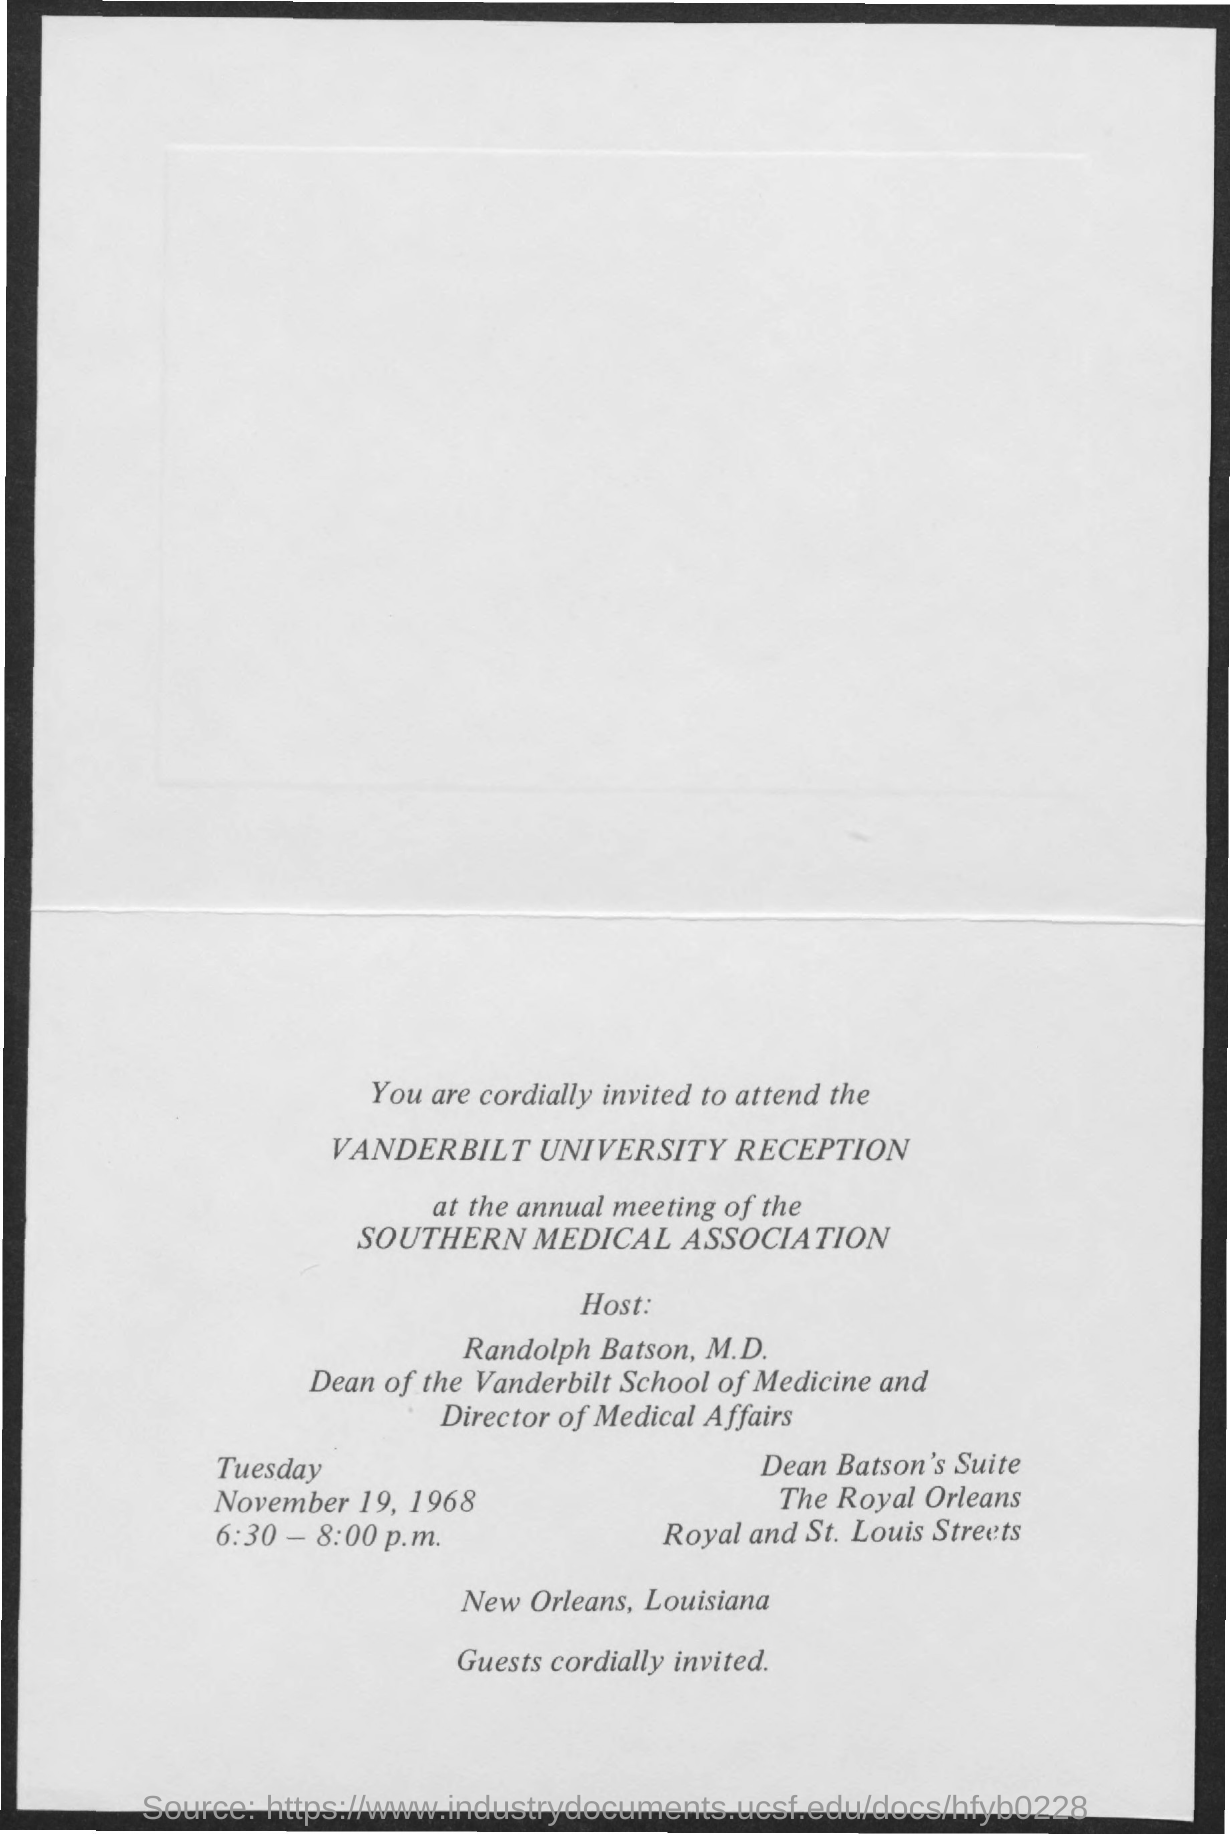Who is the host at Vanderbilt University Reception?
Your answer should be compact. Randolph Batson, M.D. What is the designation of Randolph Batson, M.D.?
Ensure brevity in your answer.  Dean of the Vanderbilt School of Medicine and Director of Medical Affairs. What time is the Vanderbilt University reception at the annual meeting of Southern Medical Association held?
Offer a terse response. 6:30 - 8:00 p.m. 